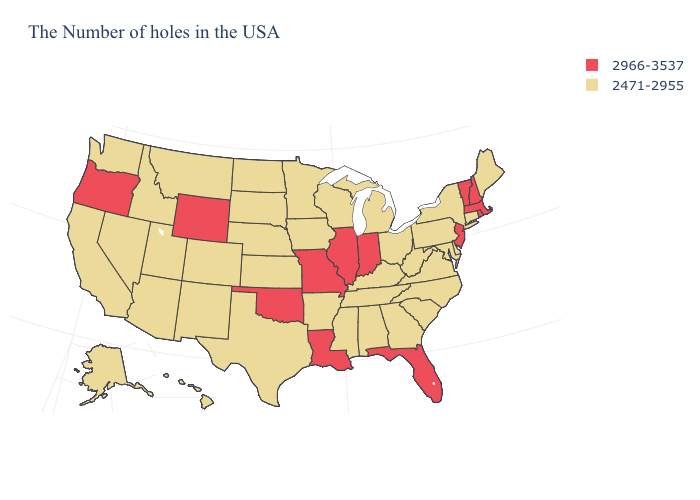What is the highest value in states that border West Virginia?
Be succinct. 2471-2955. Among the states that border California , does Arizona have the lowest value?
Keep it brief. Yes. Among the states that border Florida , which have the highest value?
Answer briefly. Georgia, Alabama. What is the value of Illinois?
Answer briefly. 2966-3537. What is the value of California?
Keep it brief. 2471-2955. What is the highest value in the South ?
Be succinct. 2966-3537. Does Massachusetts have the lowest value in the Northeast?
Write a very short answer. No. Which states have the lowest value in the USA?
Give a very brief answer. Maine, Connecticut, New York, Delaware, Maryland, Pennsylvania, Virginia, North Carolina, South Carolina, West Virginia, Ohio, Georgia, Michigan, Kentucky, Alabama, Tennessee, Wisconsin, Mississippi, Arkansas, Minnesota, Iowa, Kansas, Nebraska, Texas, South Dakota, North Dakota, Colorado, New Mexico, Utah, Montana, Arizona, Idaho, Nevada, California, Washington, Alaska, Hawaii. What is the value of South Carolina?
Give a very brief answer. 2471-2955. Which states hav the highest value in the West?
Short answer required. Wyoming, Oregon. Does South Dakota have a lower value than Vermont?
Keep it brief. Yes. Name the states that have a value in the range 2966-3537?
Keep it brief. Massachusetts, Rhode Island, New Hampshire, Vermont, New Jersey, Florida, Indiana, Illinois, Louisiana, Missouri, Oklahoma, Wyoming, Oregon. Does New Jersey have the highest value in the Northeast?
Answer briefly. Yes. What is the value of Missouri?
Give a very brief answer. 2966-3537. Name the states that have a value in the range 2471-2955?
Keep it brief. Maine, Connecticut, New York, Delaware, Maryland, Pennsylvania, Virginia, North Carolina, South Carolina, West Virginia, Ohio, Georgia, Michigan, Kentucky, Alabama, Tennessee, Wisconsin, Mississippi, Arkansas, Minnesota, Iowa, Kansas, Nebraska, Texas, South Dakota, North Dakota, Colorado, New Mexico, Utah, Montana, Arizona, Idaho, Nevada, California, Washington, Alaska, Hawaii. 